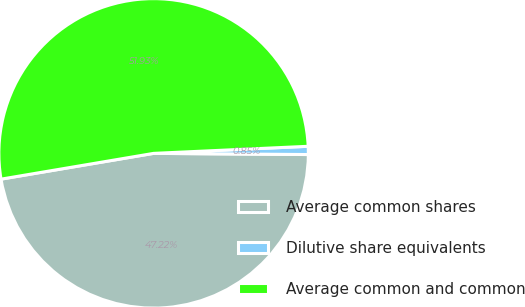Convert chart to OTSL. <chart><loc_0><loc_0><loc_500><loc_500><pie_chart><fcel>Average common shares<fcel>Dilutive share equivalents<fcel>Average common and common<nl><fcel>47.22%<fcel>0.85%<fcel>51.94%<nl></chart> 